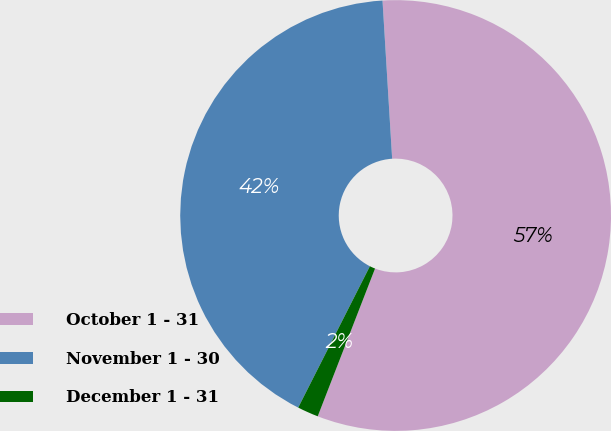<chart> <loc_0><loc_0><loc_500><loc_500><pie_chart><fcel>October 1 - 31<fcel>November 1 - 30<fcel>December 1 - 31<nl><fcel>56.86%<fcel>41.56%<fcel>1.58%<nl></chart> 